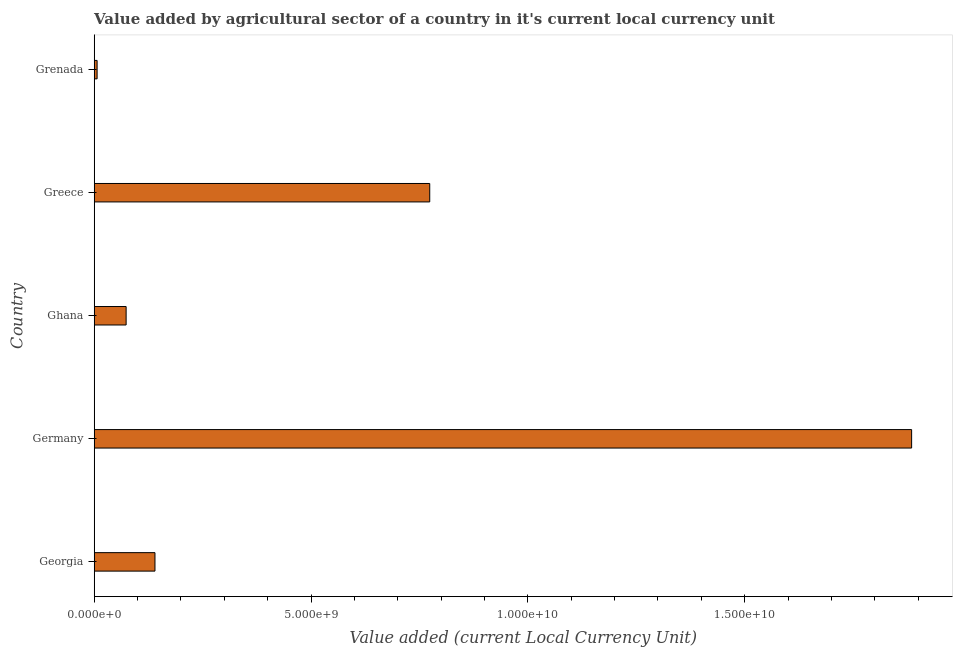Does the graph contain any zero values?
Your answer should be very brief. No. What is the title of the graph?
Provide a short and direct response. Value added by agricultural sector of a country in it's current local currency unit. What is the label or title of the X-axis?
Your response must be concise. Value added (current Local Currency Unit). What is the value added by agriculture sector in Georgia?
Make the answer very short. 1.40e+09. Across all countries, what is the maximum value added by agriculture sector?
Offer a very short reply. 1.88e+1. Across all countries, what is the minimum value added by agriculture sector?
Ensure brevity in your answer.  6.72e+07. In which country was the value added by agriculture sector maximum?
Your response must be concise. Germany. In which country was the value added by agriculture sector minimum?
Offer a terse response. Grenada. What is the sum of the value added by agriculture sector?
Offer a terse response. 2.88e+1. What is the difference between the value added by agriculture sector in Georgia and Greece?
Keep it short and to the point. -6.34e+09. What is the average value added by agriculture sector per country?
Your answer should be compact. 5.76e+09. What is the median value added by agriculture sector?
Provide a short and direct response. 1.40e+09. What is the ratio of the value added by agriculture sector in Ghana to that in Grenada?
Provide a succinct answer. 10.96. Is the value added by agriculture sector in Greece less than that in Grenada?
Keep it short and to the point. No. Is the difference between the value added by agriculture sector in Georgia and Greece greater than the difference between any two countries?
Your response must be concise. No. What is the difference between the highest and the second highest value added by agriculture sector?
Give a very brief answer. 1.11e+1. What is the difference between the highest and the lowest value added by agriculture sector?
Make the answer very short. 1.88e+1. In how many countries, is the value added by agriculture sector greater than the average value added by agriculture sector taken over all countries?
Provide a succinct answer. 2. How many bars are there?
Give a very brief answer. 5. Are all the bars in the graph horizontal?
Provide a short and direct response. Yes. How many countries are there in the graph?
Give a very brief answer. 5. What is the difference between two consecutive major ticks on the X-axis?
Offer a very short reply. 5.00e+09. What is the Value added (current Local Currency Unit) in Georgia?
Make the answer very short. 1.40e+09. What is the Value added (current Local Currency Unit) in Germany?
Offer a terse response. 1.88e+1. What is the Value added (current Local Currency Unit) of Ghana?
Your answer should be compact. 7.36e+08. What is the Value added (current Local Currency Unit) of Greece?
Make the answer very short. 7.74e+09. What is the Value added (current Local Currency Unit) of Grenada?
Your answer should be very brief. 6.72e+07. What is the difference between the Value added (current Local Currency Unit) in Georgia and Germany?
Your answer should be very brief. -1.74e+1. What is the difference between the Value added (current Local Currency Unit) in Georgia and Ghana?
Your response must be concise. 6.65e+08. What is the difference between the Value added (current Local Currency Unit) in Georgia and Greece?
Offer a very short reply. -6.34e+09. What is the difference between the Value added (current Local Currency Unit) in Georgia and Grenada?
Provide a succinct answer. 1.33e+09. What is the difference between the Value added (current Local Currency Unit) in Germany and Ghana?
Ensure brevity in your answer.  1.81e+1. What is the difference between the Value added (current Local Currency Unit) in Germany and Greece?
Keep it short and to the point. 1.11e+1. What is the difference between the Value added (current Local Currency Unit) in Germany and Grenada?
Your answer should be very brief. 1.88e+1. What is the difference between the Value added (current Local Currency Unit) in Ghana and Greece?
Your response must be concise. -7.00e+09. What is the difference between the Value added (current Local Currency Unit) in Ghana and Grenada?
Provide a short and direct response. 6.69e+08. What is the difference between the Value added (current Local Currency Unit) in Greece and Grenada?
Make the answer very short. 7.67e+09. What is the ratio of the Value added (current Local Currency Unit) in Georgia to that in Germany?
Offer a very short reply. 0.07. What is the ratio of the Value added (current Local Currency Unit) in Georgia to that in Ghana?
Provide a succinct answer. 1.9. What is the ratio of the Value added (current Local Currency Unit) in Georgia to that in Greece?
Keep it short and to the point. 0.18. What is the ratio of the Value added (current Local Currency Unit) in Georgia to that in Grenada?
Make the answer very short. 20.86. What is the ratio of the Value added (current Local Currency Unit) in Germany to that in Ghana?
Your response must be concise. 25.6. What is the ratio of the Value added (current Local Currency Unit) in Germany to that in Greece?
Offer a terse response. 2.44. What is the ratio of the Value added (current Local Currency Unit) in Germany to that in Grenada?
Offer a very short reply. 280.51. What is the ratio of the Value added (current Local Currency Unit) in Ghana to that in Greece?
Give a very brief answer. 0.1. What is the ratio of the Value added (current Local Currency Unit) in Ghana to that in Grenada?
Your answer should be very brief. 10.96. What is the ratio of the Value added (current Local Currency Unit) in Greece to that in Grenada?
Your response must be concise. 115.14. 